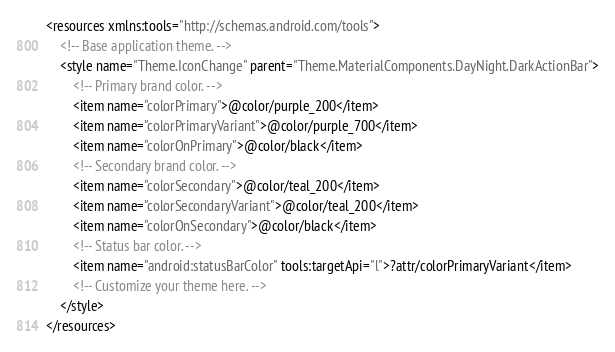Convert code to text. <code><loc_0><loc_0><loc_500><loc_500><_XML_><resources xmlns:tools="http://schemas.android.com/tools">
    <!-- Base application theme. -->
    <style name="Theme.IconChange" parent="Theme.MaterialComponents.DayNight.DarkActionBar">
        <!-- Primary brand color. -->
        <item name="colorPrimary">@color/purple_200</item>
        <item name="colorPrimaryVariant">@color/purple_700</item>
        <item name="colorOnPrimary">@color/black</item>
        <!-- Secondary brand color. -->
        <item name="colorSecondary">@color/teal_200</item>
        <item name="colorSecondaryVariant">@color/teal_200</item>
        <item name="colorOnSecondary">@color/black</item>
        <!-- Status bar color. -->
        <item name="android:statusBarColor" tools:targetApi="l">?attr/colorPrimaryVariant</item>
        <!-- Customize your theme here. -->
    </style>
</resources></code> 